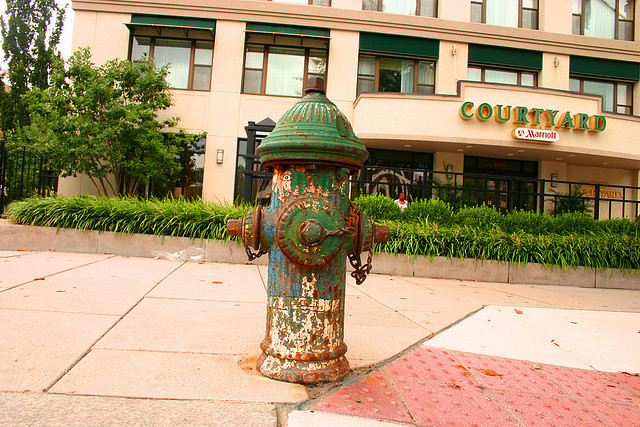Read all the text in this image. COURTYARD 